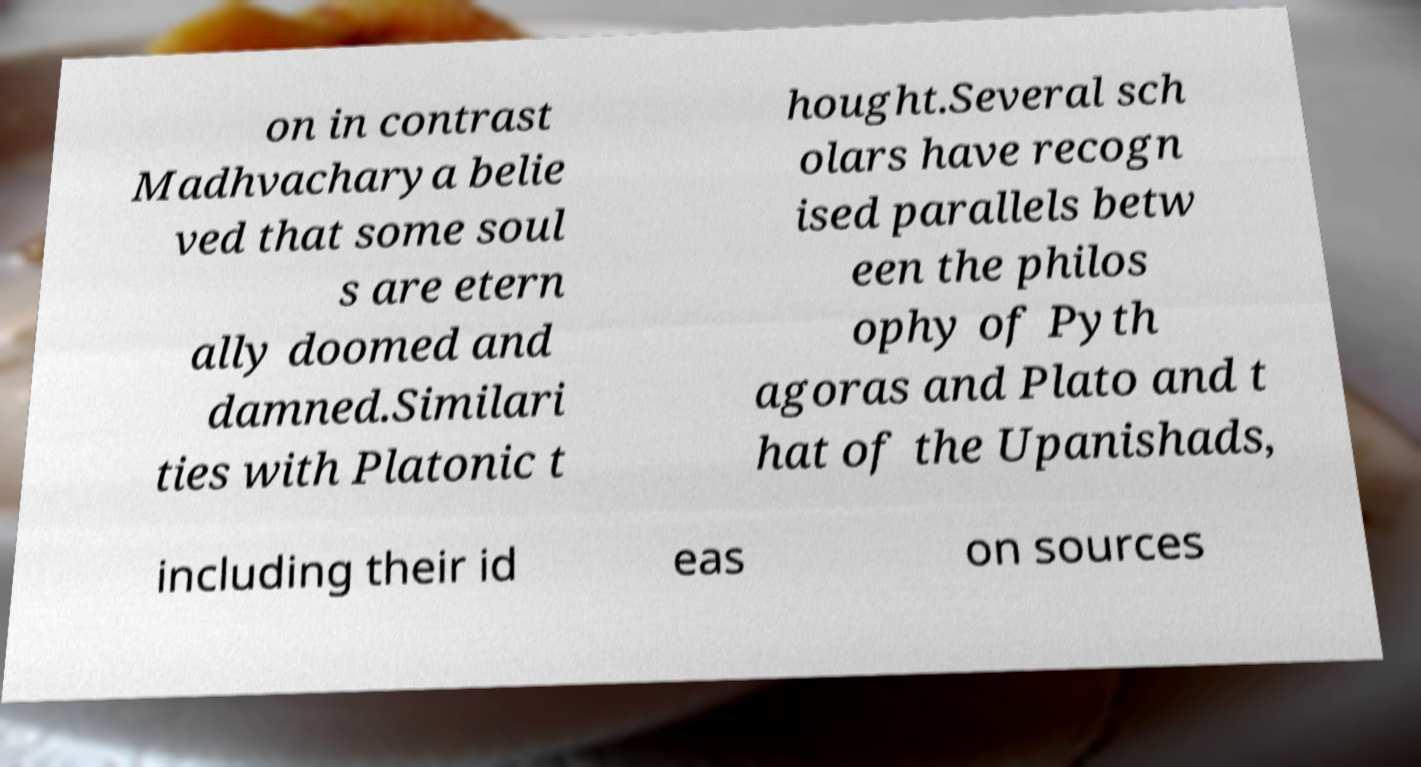Please identify and transcribe the text found in this image. on in contrast Madhvacharya belie ved that some soul s are etern ally doomed and damned.Similari ties with Platonic t hought.Several sch olars have recogn ised parallels betw een the philos ophy of Pyth agoras and Plato and t hat of the Upanishads, including their id eas on sources 